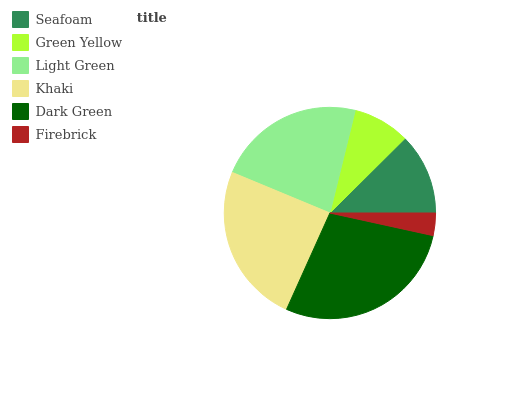Is Firebrick the minimum?
Answer yes or no. Yes. Is Dark Green the maximum?
Answer yes or no. Yes. Is Green Yellow the minimum?
Answer yes or no. No. Is Green Yellow the maximum?
Answer yes or no. No. Is Seafoam greater than Green Yellow?
Answer yes or no. Yes. Is Green Yellow less than Seafoam?
Answer yes or no. Yes. Is Green Yellow greater than Seafoam?
Answer yes or no. No. Is Seafoam less than Green Yellow?
Answer yes or no. No. Is Light Green the high median?
Answer yes or no. Yes. Is Seafoam the low median?
Answer yes or no. Yes. Is Khaki the high median?
Answer yes or no. No. Is Light Green the low median?
Answer yes or no. No. 